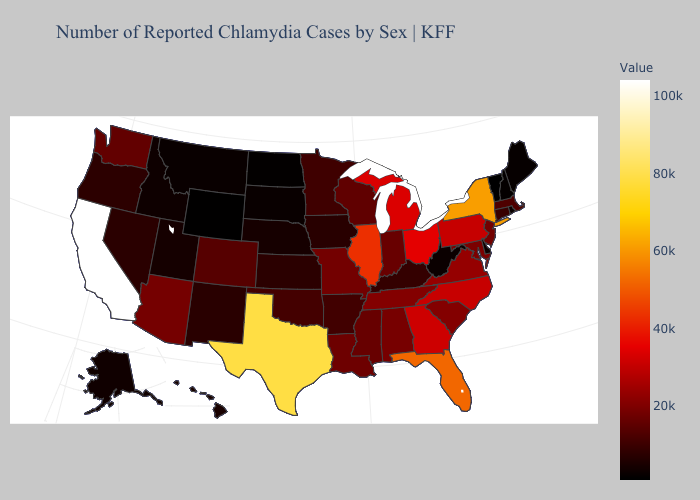Does Louisiana have a lower value than Florida?
Keep it brief. Yes. Is the legend a continuous bar?
Be succinct. Yes. Among the states that border Colorado , which have the lowest value?
Write a very short answer. Wyoming. Among the states that border Nevada , does California have the highest value?
Quick response, please. Yes. Does Connecticut have the highest value in the USA?
Quick response, please. No. Does the map have missing data?
Be succinct. No. 